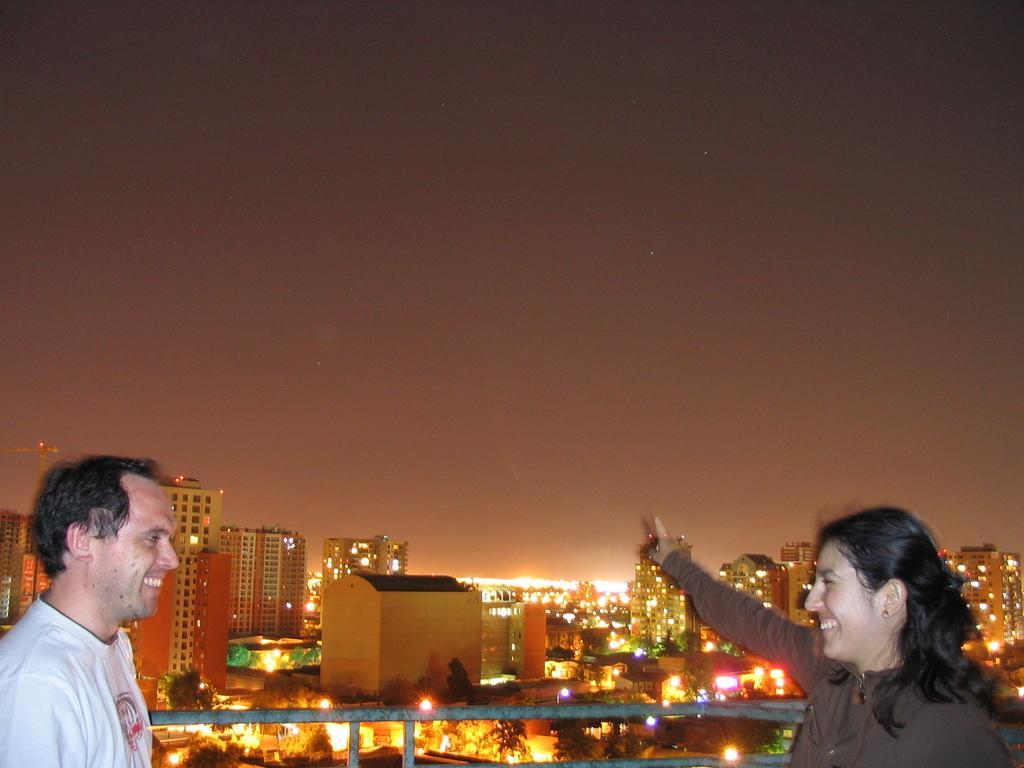Could you give a brief overview of what you see in this image? On the left side, there is a person in white color t-shirt smiling and standing. On the right side, there is a person in a t-shirt smiling, standing and showing something. In the background, there is a fencing, there are buildings which are glass windows and lights, there are trees, there are lights and there is sky. 